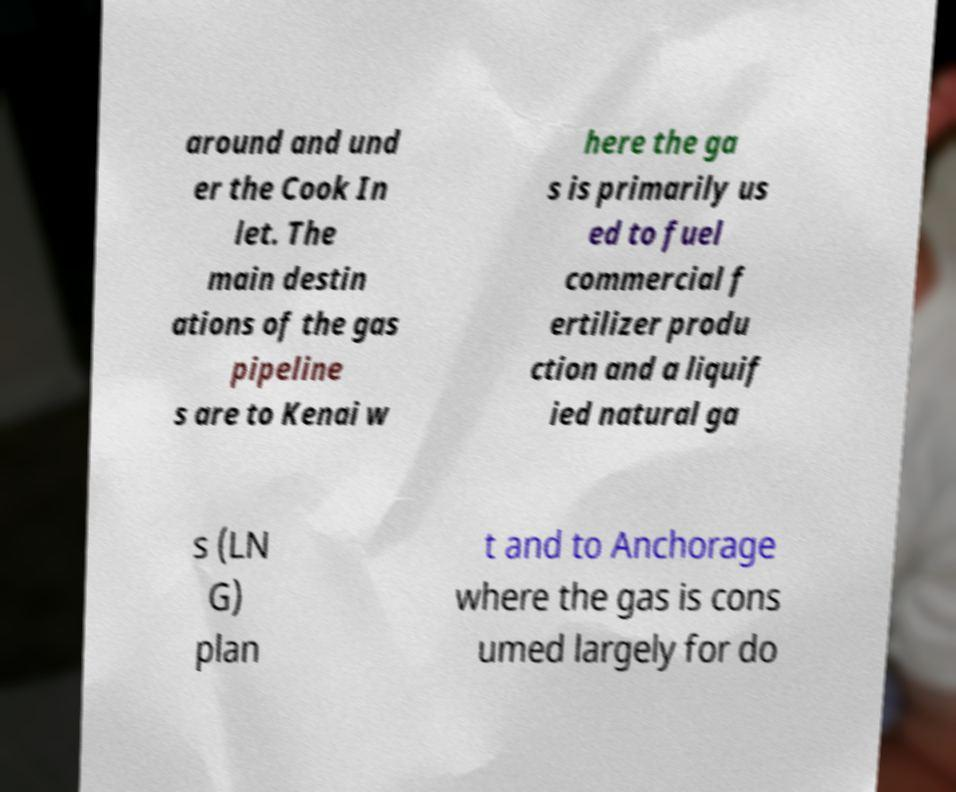I need the written content from this picture converted into text. Can you do that? around and und er the Cook In let. The main destin ations of the gas pipeline s are to Kenai w here the ga s is primarily us ed to fuel commercial f ertilizer produ ction and a liquif ied natural ga s (LN G) plan t and to Anchorage where the gas is cons umed largely for do 